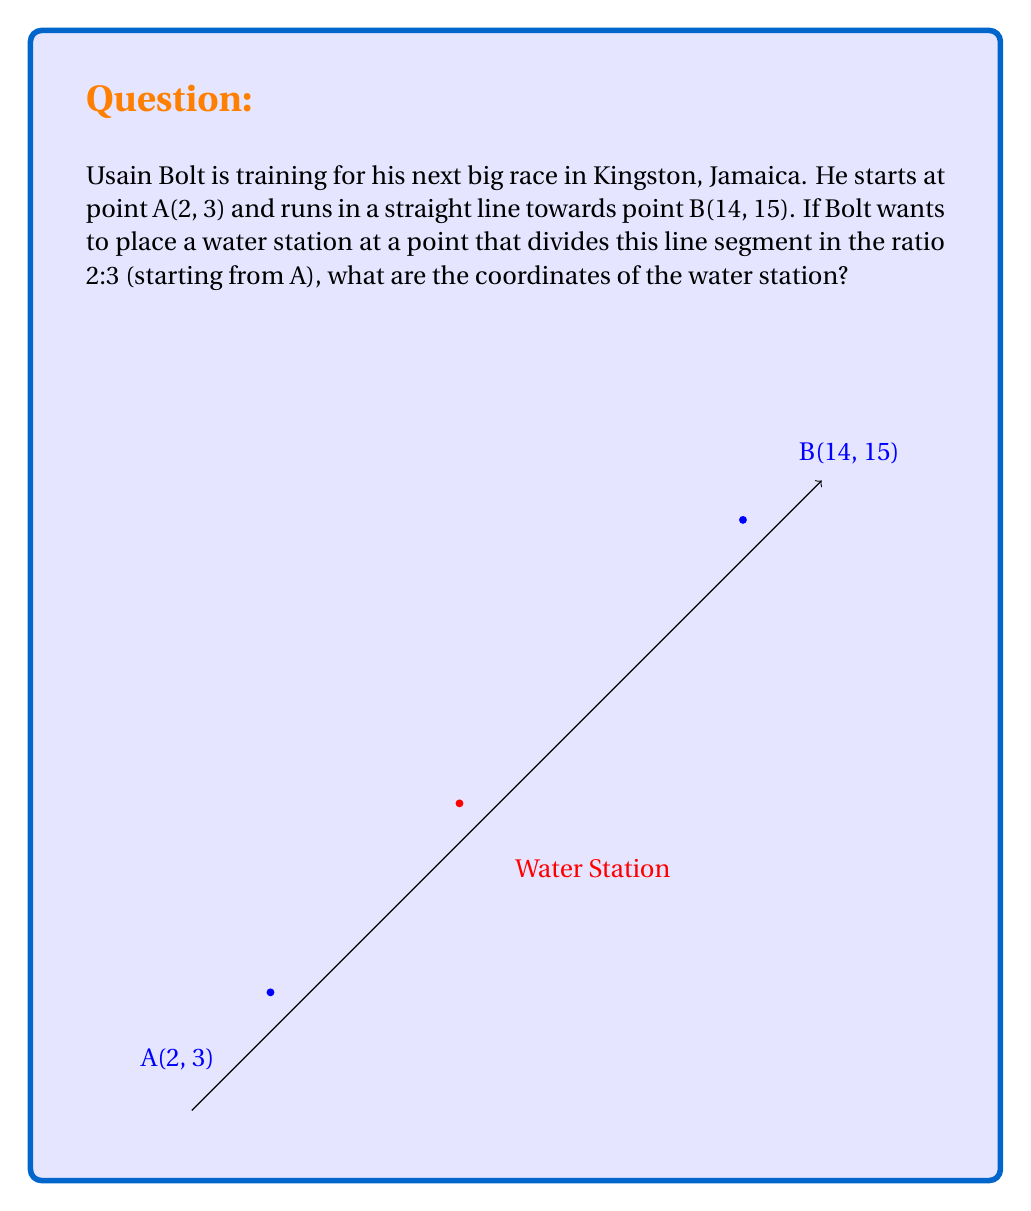Give your solution to this math problem. Let's solve this step-by-step:

1) We can use the section formula to find the coordinates of the point that divides the line segment AB in the ratio 2:3. The general formula is:

   $$(x, y) = (\frac{m_2x_1 + m_1x_2}{m_1 + m_2}, \frac{m_2y_1 + m_1y_2}{m_1 + m_2})$$

   Where $(x_1, y_1)$ is the starting point, $(x_2, y_2)$ is the endpoint, and $m_1:m_2$ is the ratio.

2) In this case:
   $(x_1, y_1) = (2, 3)$
   $(x_2, y_2) = (14, 15)$
   $m_1 : m_2 = 2 : 3$

3) Let's substitute these values into the formula:

   $$x = \frac{3(2) + 2(14)}{2 + 3} = \frac{6 + 28}{5} = \frac{34}{5} = 6.8$$

   $$y = \frac{3(3) + 2(15)}{2 + 3} = \frac{9 + 30}{5} = \frac{39}{5} = 7.8$$

4) Therefore, the coordinates of the water station are (6.8, 7.8).

5) We can verify this result:
   - The distance from A to the water station should be 2/5 of the total distance.
   - The distance from the water station to B should be 3/5 of the total distance.
Answer: (6.8, 7.8) 